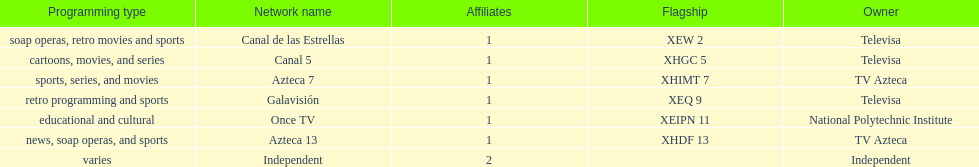What is the number of networks that are owned by televisa? 3. 